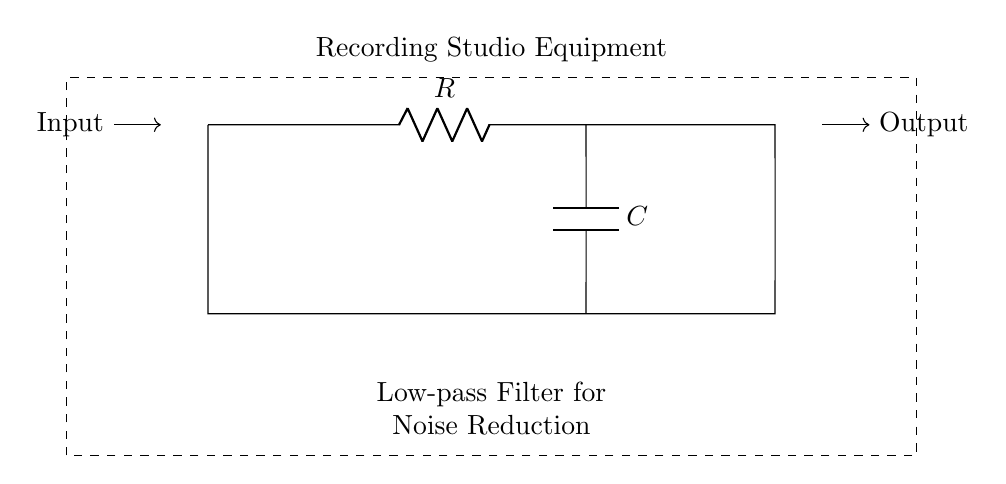What are the two main components in this circuit? The circuit diagram clearly shows a resistor denoted by "R" and a capacitor denoted by "C". These labels indicate the two main components used in the low-pass filter design.
Answer: Resistor, Capacitor What is the purpose of this circuit? The label in the circuit diagram specifically states that it is a "Low-pass Filter for Noise Reduction". This indicates the circuit's primary function, which is to allow low-frequency signals to pass while attenuating high-frequency noise.
Answer: Noise Reduction What is the connection type used between the resistor and capacitor? In the circuit diagram, the resistor and capacitor are connected in series, as there is a direct line shown connecting R to C without any branching. This denotes that the current must pass through the resistor before reaching the capacitor.
Answer: Series What happens to high-frequency signals in this circuit? The function of a low-pass filter is to attenuate or diminish high-frequency signals. Thus, in this setup, as high-frequency signals attempt to pass through, effectively they get reduced in amplitude and are suppressed.
Answer: They are attenuated What is the expected output of this circuit when a sine wave input is applied? Since the circuit is designed as a low-pass filter, the output would retain the lower frequency components of the sine wave while the higher frequency components would be diminished. Thus the output will primarily be the low-frequency portion of the input signal.
Answer: Low-frequency sine wave What effect does increasing the capacitor value have on the filter's performance? Increasing the capacitance typically lowers the cutoff frequency of the filter. This means that a broader range of lower frequencies will be allowed to pass through the circuit unimpeded, while higher frequencies will be further attenuated.
Answer: Lowers cutoff frequency What is the role of the resistor in this circuit? The resistor in this low-pass filter setup controls the rate at which the capacitor charges and discharges, thereby influencing the filter's time constant and ultimately determining how quickly the circuit responds to changes in input frequency signals.
Answer: Controls time constant 